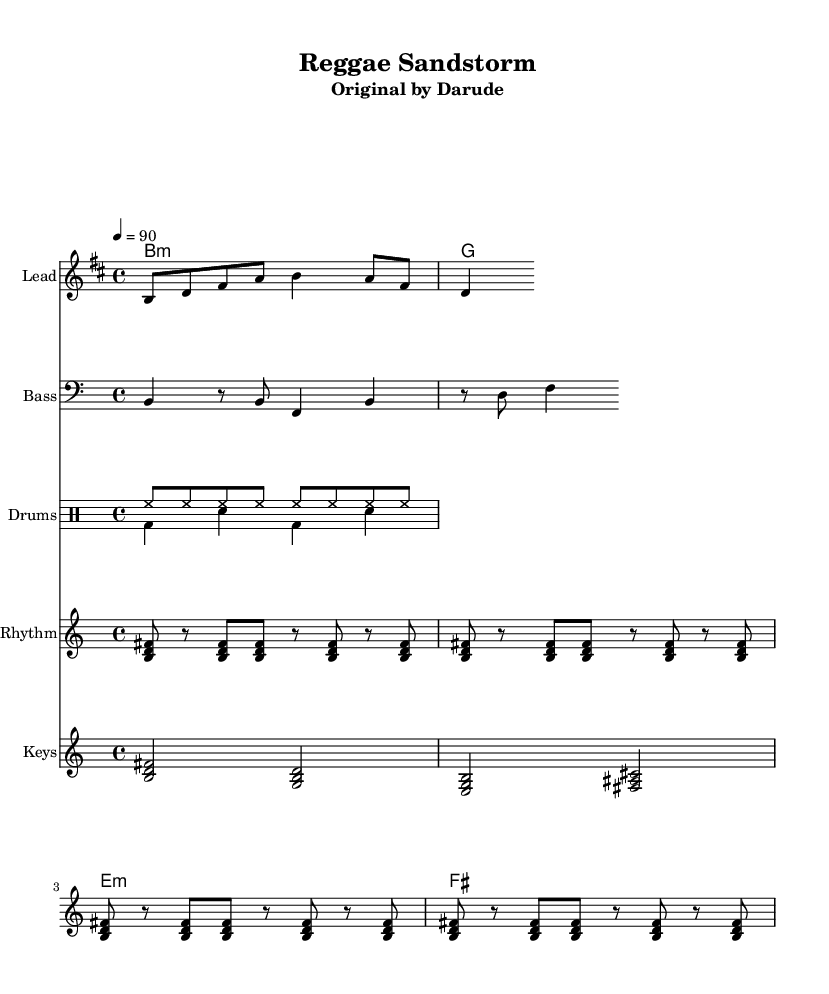What is the key signature of this music? The key signature shows a B minor key, which has two sharps (F# and C#). This is indicated by the presence of two sharp symbols at the beginning of the staff.
Answer: B minor What is the time signature of this music? The time signature is found at the beginning of the sheet music, clearly indicated as 4/4, meaning four beats in each measure and a quarter note receives one beat.
Answer: 4/4 What is the tempo marking for this piece? The tempo marking is shown as "4 = 90," which indicates that there are 90 beats per minute, meaning each quarter note is played at this pace.
Answer: 90 How many bars are in the melody section? By counting the measures in the melody staff, there are a total of 5 bars present, confirming the melody's structure.
Answer: 5 Which instruments are included in this arrangement? The arrangement consists of a Lead instrument for melody, a Bass, Drums, Rhythm Guitar, and Keys, all of which are depicted as separate staves in the score.
Answer: Lead, Bass, Drums, Rhythm Guitar, Keys Which chords are used in the harmony section? The harmony section contains B minor (b:m), G major, E minor (e:m), and F# major chords. These are represented in the chord symbol notation within the score.
Answer: B minor, G, E minor, F# major What is the main rhythmic pattern used in the drums section? The main rhythmic pattern features a hi-hat on every eighth note and a kick and snare pattern that alternates, showing a consistent reggae groove typical in this genre.
Answer: Hi-hat and kick-snare pattern 